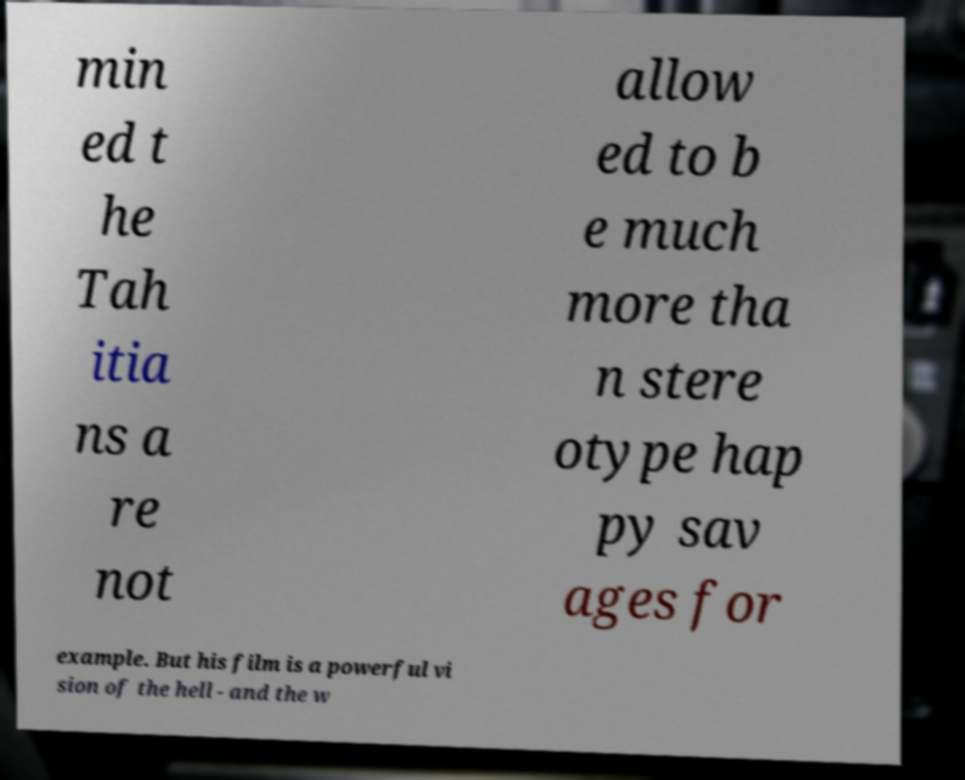Please identify and transcribe the text found in this image. min ed t he Tah itia ns a re not allow ed to b e much more tha n stere otype hap py sav ages for example. But his film is a powerful vi sion of the hell - and the w 